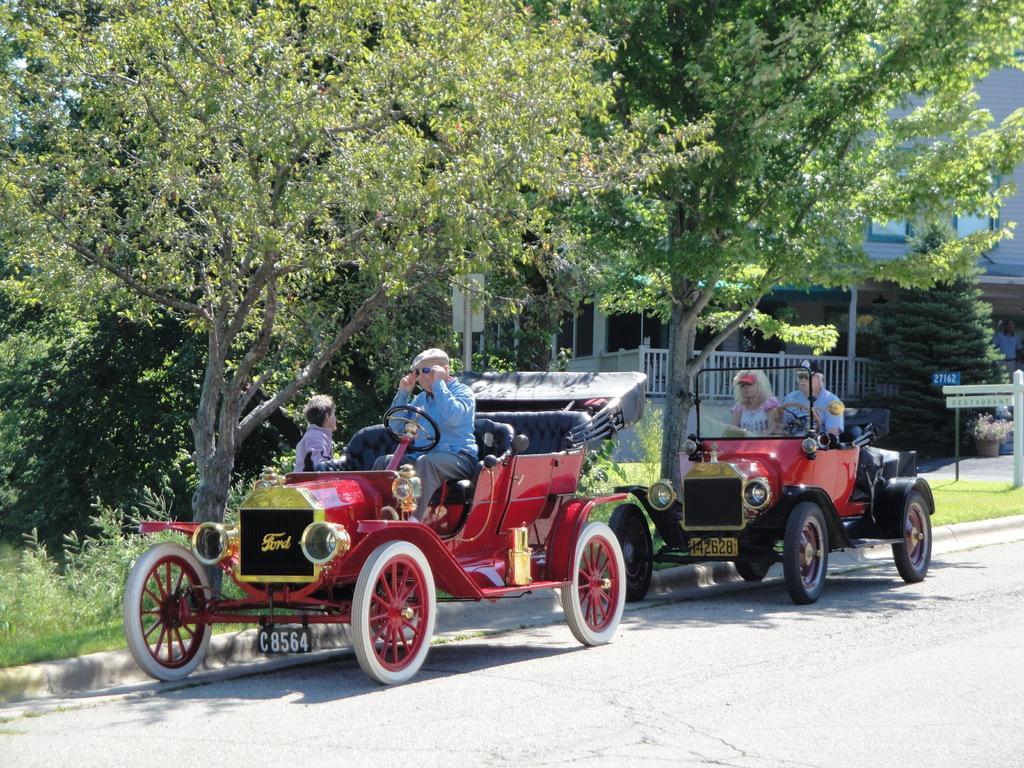How would you summarize this image in a sentence or two? In this image in the center there are some vehicles, and in the vehicles there are some persons sitting. And in the background there are some buildings, trees and on the right side there are some boards and pole and in the center I can see some poles at the bottom there is road and grass. 